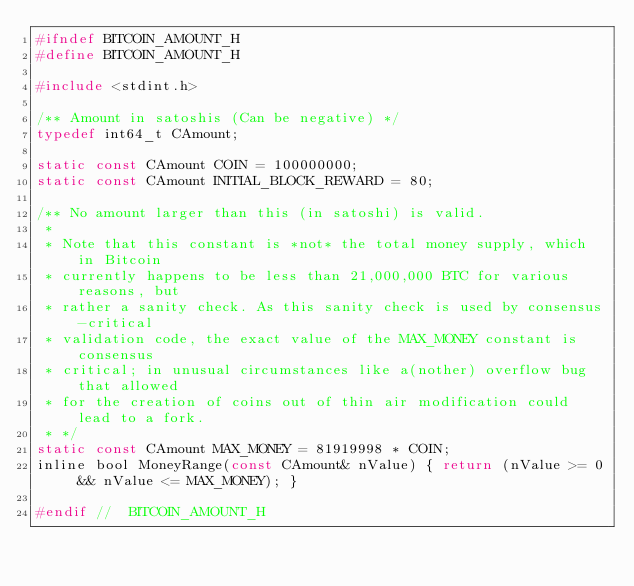Convert code to text. <code><loc_0><loc_0><loc_500><loc_500><_C_>#ifndef BITCOIN_AMOUNT_H
#define BITCOIN_AMOUNT_H

#include <stdint.h>

/** Amount in satoshis (Can be negative) */
typedef int64_t CAmount;

static const CAmount COIN = 100000000;
static const CAmount INITIAL_BLOCK_REWARD = 80;

/** No amount larger than this (in satoshi) is valid.
 *
 * Note that this constant is *not* the total money supply, which in Bitcoin
 * currently happens to be less than 21,000,000 BTC for various reasons, but
 * rather a sanity check. As this sanity check is used by consensus-critical
 * validation code, the exact value of the MAX_MONEY constant is consensus
 * critical; in unusual circumstances like a(nother) overflow bug that allowed
 * for the creation of coins out of thin air modification could lead to a fork.
 * */
static const CAmount MAX_MONEY = 81919998 * COIN;
inline bool MoneyRange(const CAmount& nValue) { return (nValue >= 0 && nValue <= MAX_MONEY); }

#endif //  BITCOIN_AMOUNT_H
</code> 